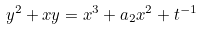<formula> <loc_0><loc_0><loc_500><loc_500>y ^ { 2 } + x y = x ^ { 3 } + a _ { 2 } x ^ { 2 } + t ^ { - 1 }</formula> 